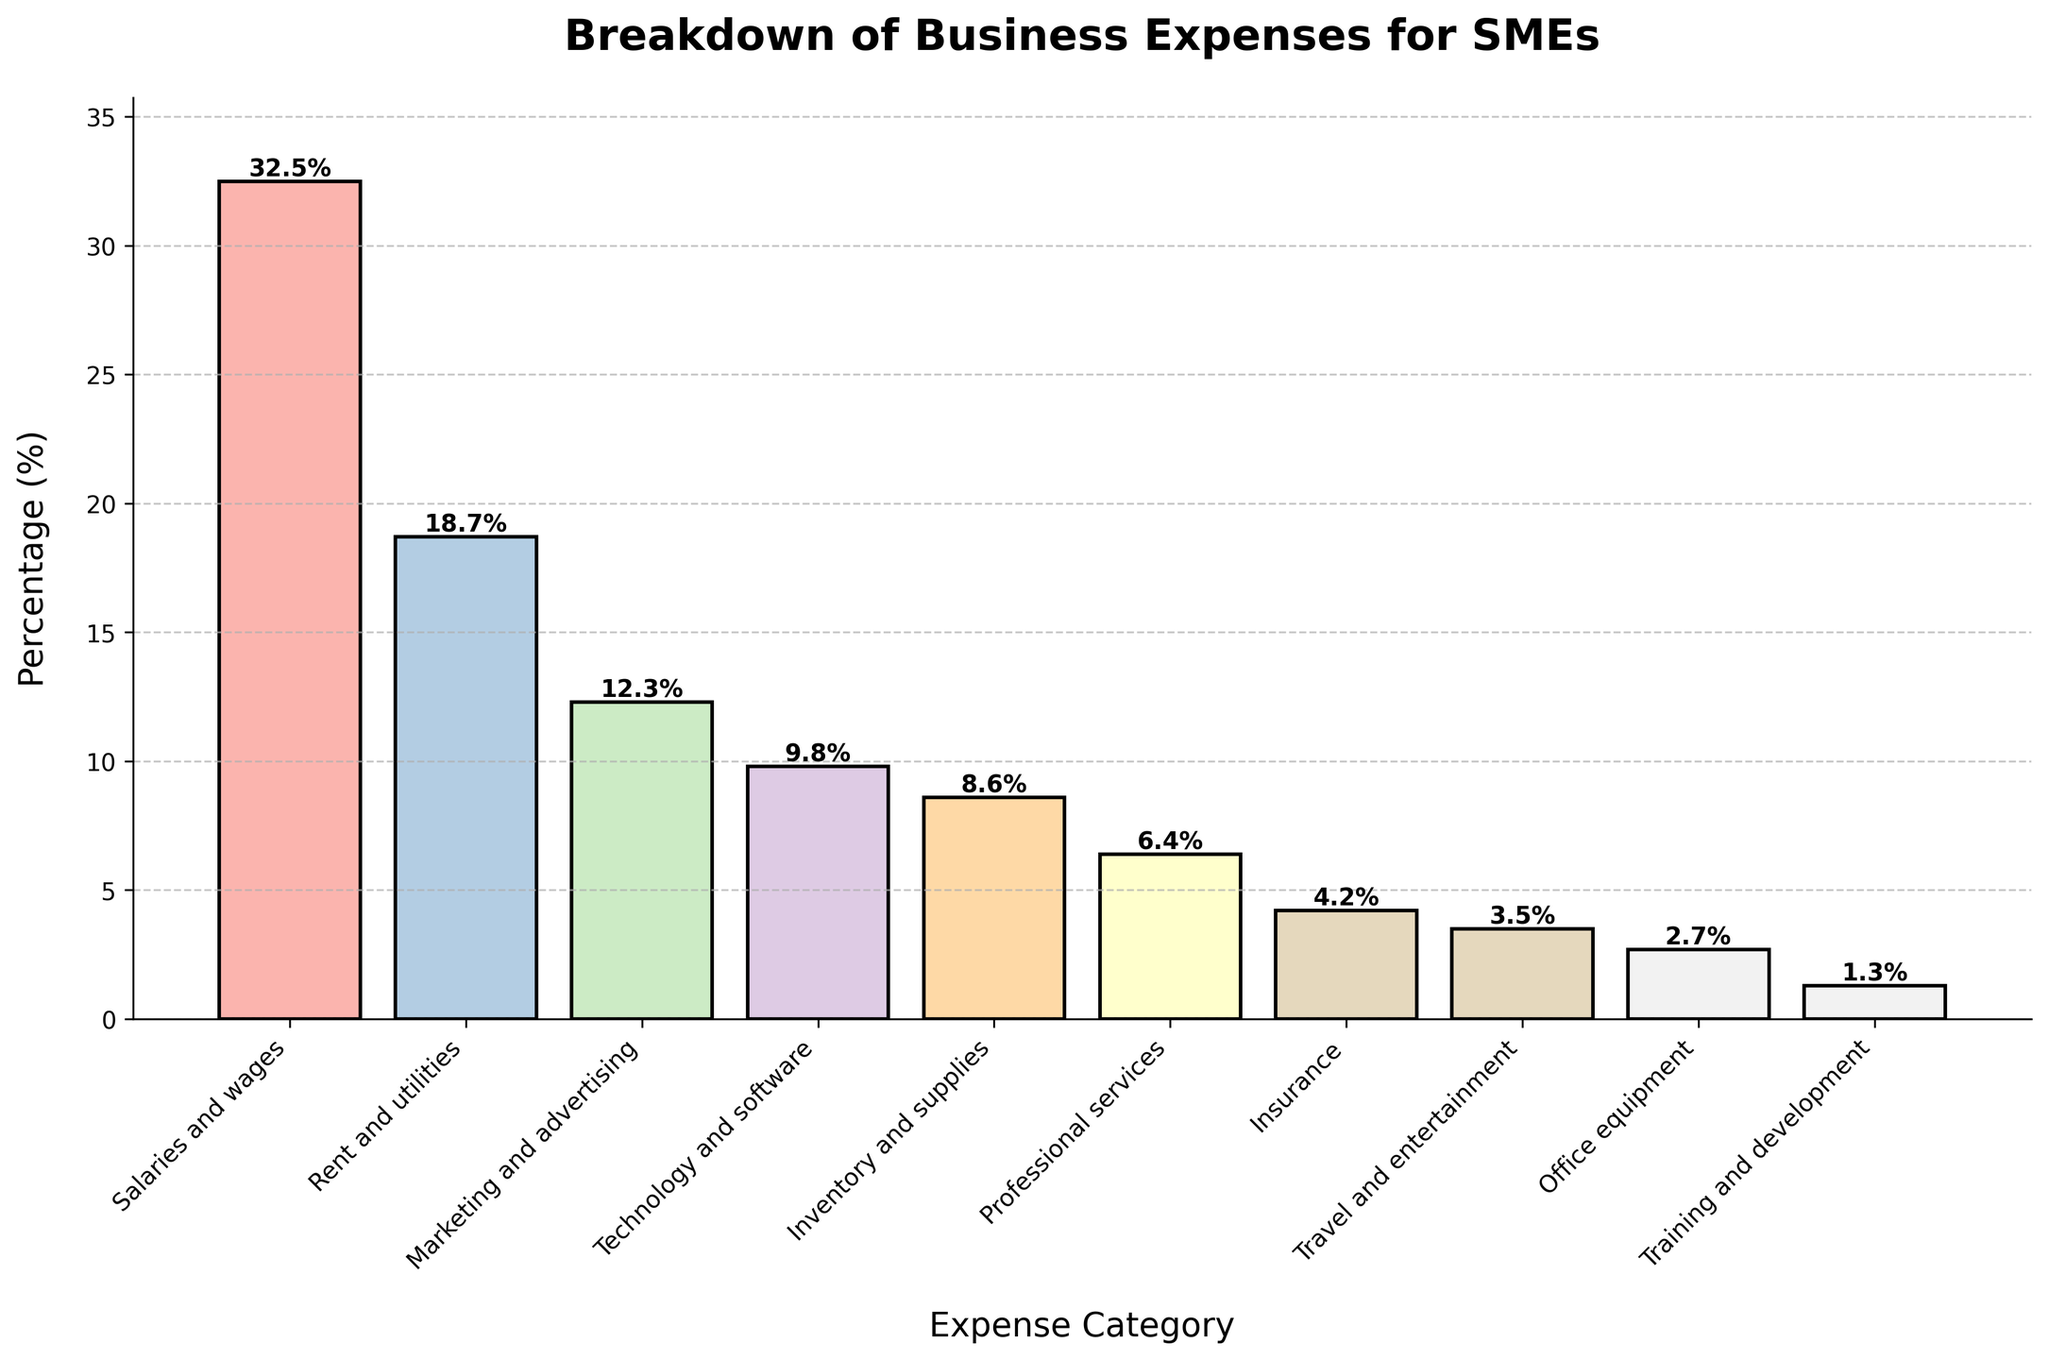What is the second largest expense category for SMEs? The second largest expense category is determined by identifying the category with the second highest percentage. From the bar chart, it is clear that "Rent and utilities" is the second largest, after "Salaries and wages".
Answer: Rent and utilities Which expense category has the least percentage? By examining the heights of the bars in the bar chart, "Training and development" has the shortest bar, indicating it has the least percentage.
Answer: Training and development What is the combined percentage of 'Marketing and advertising' and 'Technology and software'? To find the combined percentage, add the percentages of 'Marketing and advertising' (12.3) and 'Technology and software' (9.8). So, 12.3 + 9.8 = 22.1.
Answer: 22.1% Compare 'Insurance' with 'Travel and entertainment': Which category has a higher percentage and by how much? First, identify the percentages of 'Insurance' (4.2) and 'Travel and entertainment' (3.5). Then, subtract the smaller percentage from the larger percentage: 4.2 - 3.5 = 0.7. Therefore, 'Insurance' has a higher percentage by 0.7.
Answer: Insurance by 0.7% What is the total percentage covered by 'Rent and utilities', 'Inventory and supplies', and 'Professional services'? Sum the percentages of 'Rent and utilities' (18.7), 'Inventory and supplies' (8.6), and 'Professional services' (6.4). So, 18.7 + 8.6 + 6.4 = 33.7.
Answer: 33.7% Which categories have a percentage higher than 10%? From the bar chart, visually identify which bars exceed the 10% mark. These categories are 'Salaries and wages' (32.5), 'Rent and utilities' (18.7), and 'Marketing and advertising' (12.3).
Answer: Salaries and wages, Rent and utilities, Marketing and advertising How much more is spent on 'Technology and software' than on 'Office equipment'? Identify the percentages of 'Technology and software' (9.8) and 'Office equipment' (2.7). Subtract the smaller percentage from the larger: 9.8 - 2.7 = 7.1.
Answer: 7.1% Which category has the closest percentage to 'Inventory and supplies'? Identify the percentage for 'Inventory and supplies' (8.6) and compare it with other categories. 'Technology and software' at 9.8 is the closest in terms of percentage.
Answer: Technology and software Rank the top three expense categories. By examining the bar heights and respective percentages, the top three categories in descending order are 'Salaries and wages' (32.5), 'Rent and utilities' (18.7), and 'Marketing and advertising' (12.3).
Answer: Salaries and wages, Rent and utilities, Marketing and advertising 